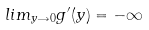Convert formula to latex. <formula><loc_0><loc_0><loc_500><loc_500>l i m _ { y \rightarrow 0 } g ^ { \prime } ( y ) = - \infty</formula> 